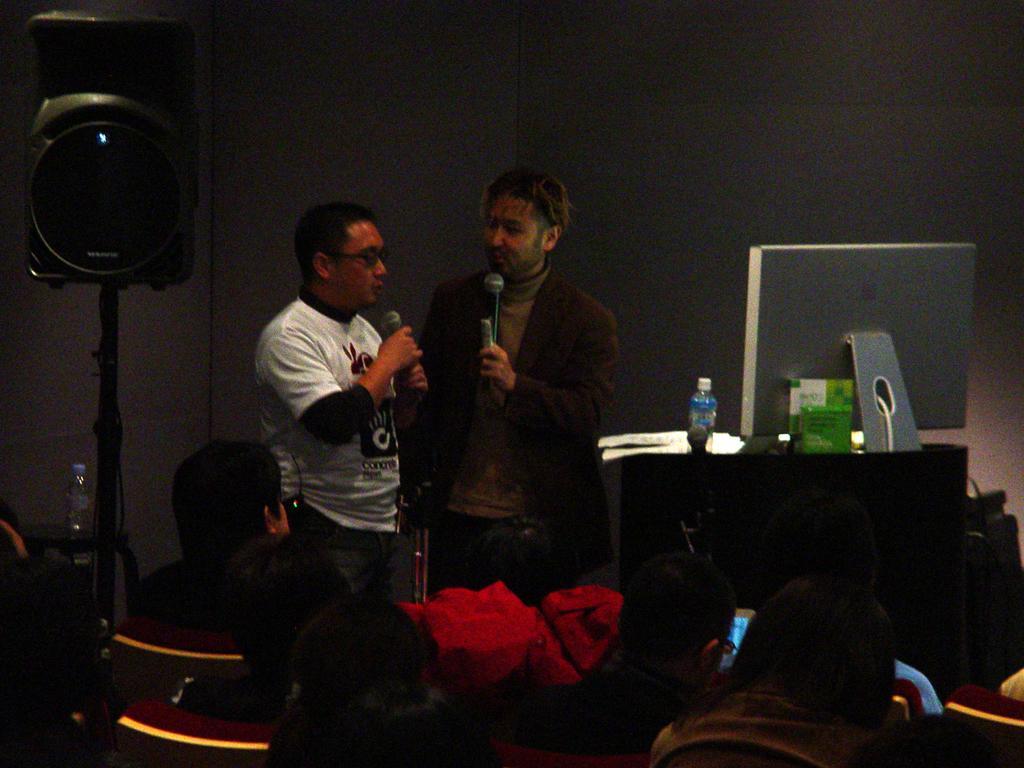Could you give a brief overview of what you see in this image? In the center of the image there are two people standing holding a mic. In the bottom of the image there are people sitting on chairs. In the background of the image there is a wall. There is a speaker to the left side of the image. To the right side of the image there is a table on which there is a bottle. There is a TV. 